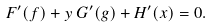<formula> <loc_0><loc_0><loc_500><loc_500>F ^ { \prime } ( f ) + y \, G ^ { \prime } ( g ) + H ^ { \prime } ( x ) = 0 .</formula> 